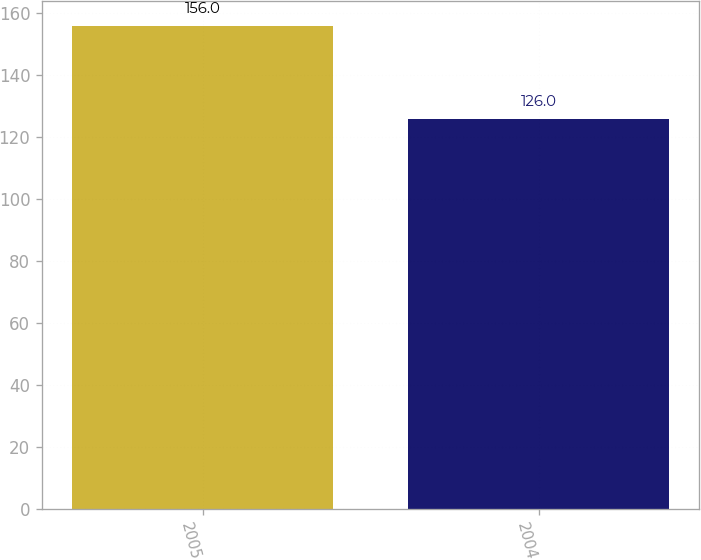Convert chart to OTSL. <chart><loc_0><loc_0><loc_500><loc_500><bar_chart><fcel>2005<fcel>2004<nl><fcel>156<fcel>126<nl></chart> 